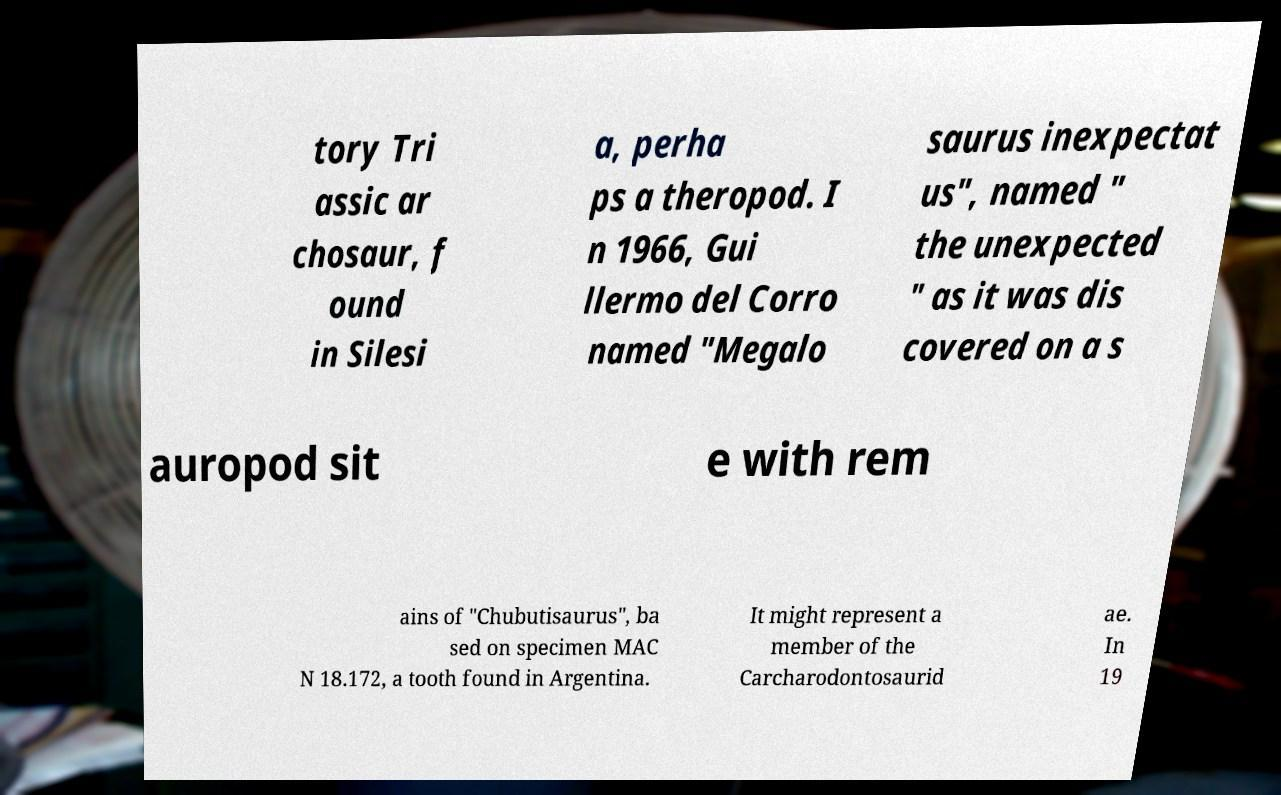What messages or text are displayed in this image? I need them in a readable, typed format. tory Tri assic ar chosaur, f ound in Silesi a, perha ps a theropod. I n 1966, Gui llermo del Corro named "Megalo saurus inexpectat us", named " the unexpected " as it was dis covered on a s auropod sit e with rem ains of "Chubutisaurus", ba sed on specimen MAC N 18.172, a tooth found in Argentina. It might represent a member of the Carcharodontosaurid ae. In 19 